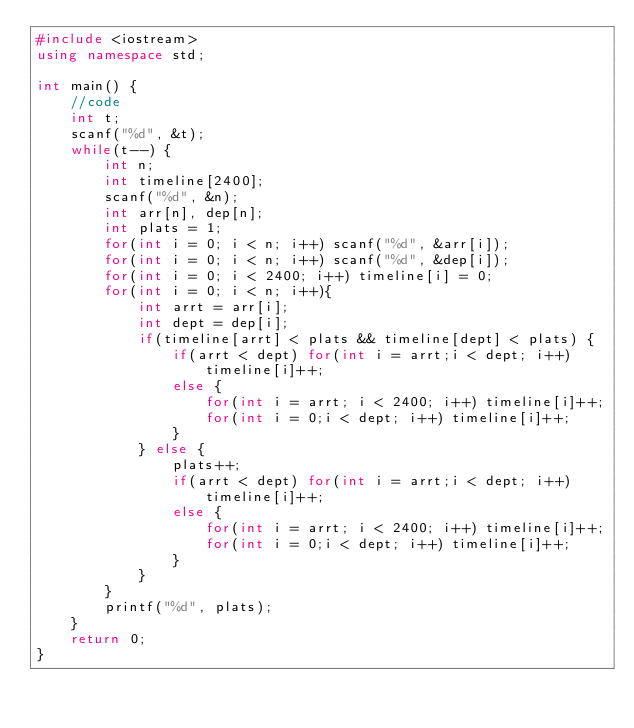<code> <loc_0><loc_0><loc_500><loc_500><_C++_>#include <iostream>
using namespace std;

int main() {
	//code
	int t;
	scanf("%d", &t);
	while(t--) {
	    int n;
	    int timeline[2400];
	    scanf("%d", &n);
	    int arr[n], dep[n];
	    int plats = 1;
	    for(int i = 0; i < n; i++) scanf("%d", &arr[i]);
	    for(int i = 0; i < n; i++) scanf("%d", &dep[i]);
	    for(int i = 0; i < 2400; i++) timeline[i] = 0;
	    for(int i = 0; i < n; i++){
	        int arrt = arr[i];
	        int dept = dep[i];
	        if(timeline[arrt] < plats && timeline[dept] < plats) {
	            if(arrt < dept) for(int i = arrt;i < dept; i++) timeline[i]++;
	            else {
	                for(int i = arrt; i < 2400; i++) timeline[i]++;
	                for(int i = 0;i < dept; i++) timeline[i]++;
	            }
	        } else {
	            plats++;
	            if(arrt < dept) for(int i = arrt;i < dept; i++) timeline[i]++;
	            else {
	                for(int i = arrt; i < 2400; i++) timeline[i]++;
	                for(int i = 0;i < dept; i++) timeline[i]++;
	            }
	        }
	    }
	    printf("%d", plats);
	}
	return 0;
}
</code> 